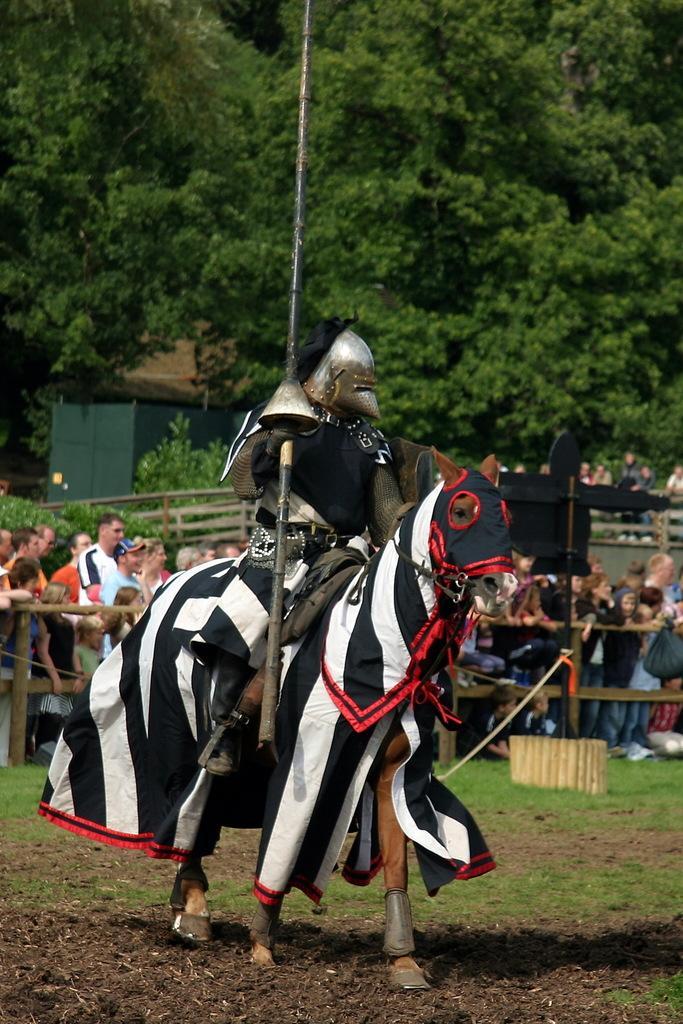How would you summarize this image in a sentence or two? In the background we can see trees. Around the people there is a fence. We can see a man sitting on a horse. At the bottom portion of the picture we can see soil and grass. 